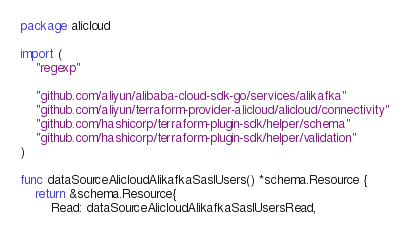Convert code to text. <code><loc_0><loc_0><loc_500><loc_500><_Go_>package alicloud

import (
	"regexp"

	"github.com/aliyun/alibaba-cloud-sdk-go/services/alikafka"
	"github.com/aliyun/terraform-provider-alicloud/alicloud/connectivity"
	"github.com/hashicorp/terraform-plugin-sdk/helper/schema"
	"github.com/hashicorp/terraform-plugin-sdk/helper/validation"
)

func dataSourceAlicloudAlikafkaSaslUsers() *schema.Resource {
	return &schema.Resource{
		Read: dataSourceAlicloudAlikafkaSaslUsersRead,
</code> 